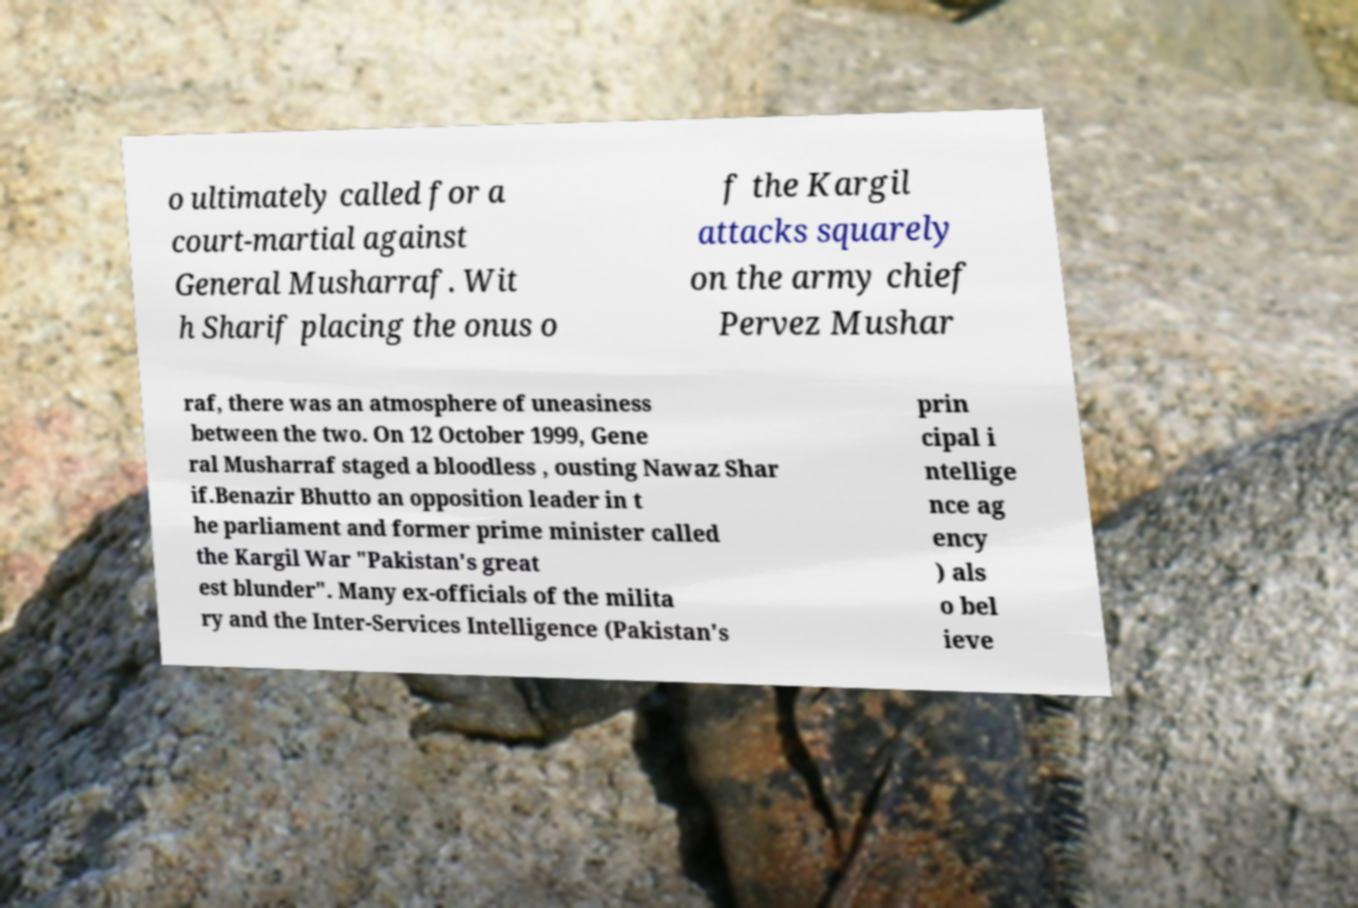What messages or text are displayed in this image? I need them in a readable, typed format. o ultimately called for a court-martial against General Musharraf. Wit h Sharif placing the onus o f the Kargil attacks squarely on the army chief Pervez Mushar raf, there was an atmosphere of uneasiness between the two. On 12 October 1999, Gene ral Musharraf staged a bloodless , ousting Nawaz Shar if.Benazir Bhutto an opposition leader in t he parliament and former prime minister called the Kargil War "Pakistan's great est blunder". Many ex-officials of the milita ry and the Inter-Services Intelligence (Pakistan's prin cipal i ntellige nce ag ency ) als o bel ieve 